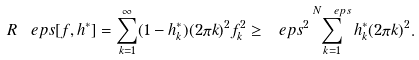<formula> <loc_0><loc_0><loc_500><loc_500>R ^ { \ } e p s [ f , h ^ { * } ] = \sum _ { k = 1 } ^ { \infty } ( 1 - h _ { k } ^ { * } ) ( 2 \pi k ) ^ { 2 } f _ { k } ^ { 2 } \geq \ e p s ^ { 2 } \sum _ { k = 1 } ^ { N _ { \ } e p s } h _ { k } ^ { * } ( 2 \pi k ) ^ { 2 } .</formula> 